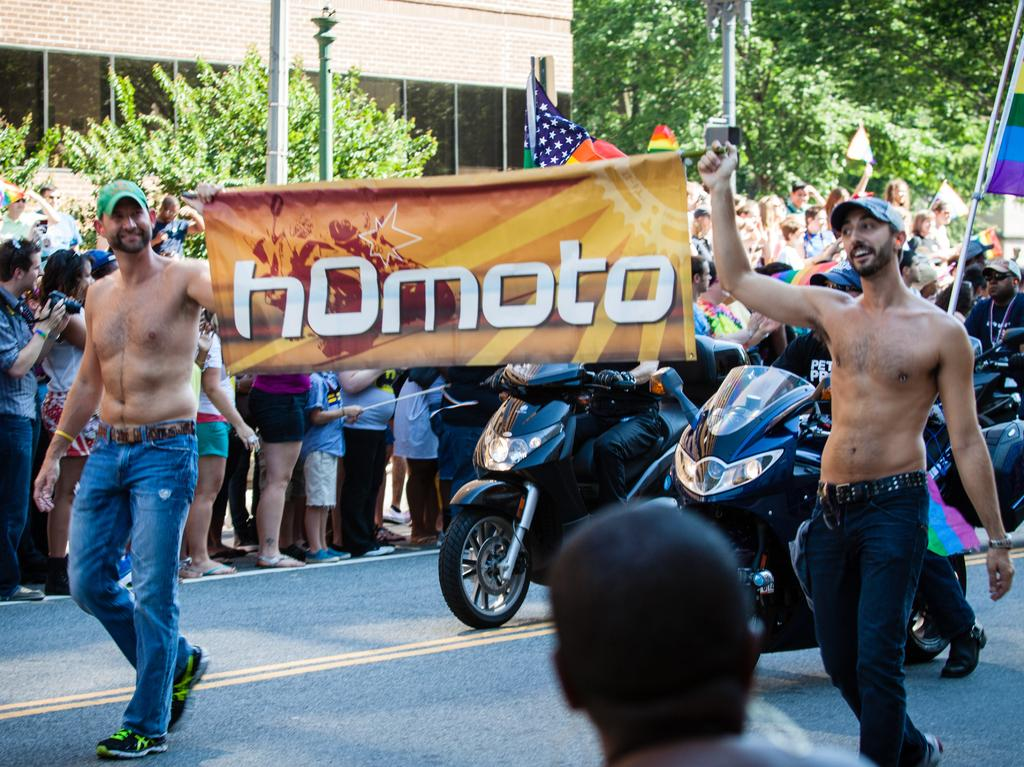How many people are visible in the image? There are people in the image, but the exact number is not specified. What are two people doing in the image? Two people are holding a poster in the image. What are the people wearing on their heads? The people are wearing caps in the image. What can be seen behind the people? There are two bikes behind the people in the image. What is visible in the background of the image? There is a building and many trees in the background of the image. What type of worm can be seen crawling on the poster in the image? There is no worm present in the image, and therefore no such activity can be observed. How much debt do the people in the image owe to the bank? There is no information about the people's financial situation in the image, so it cannot be determined. 